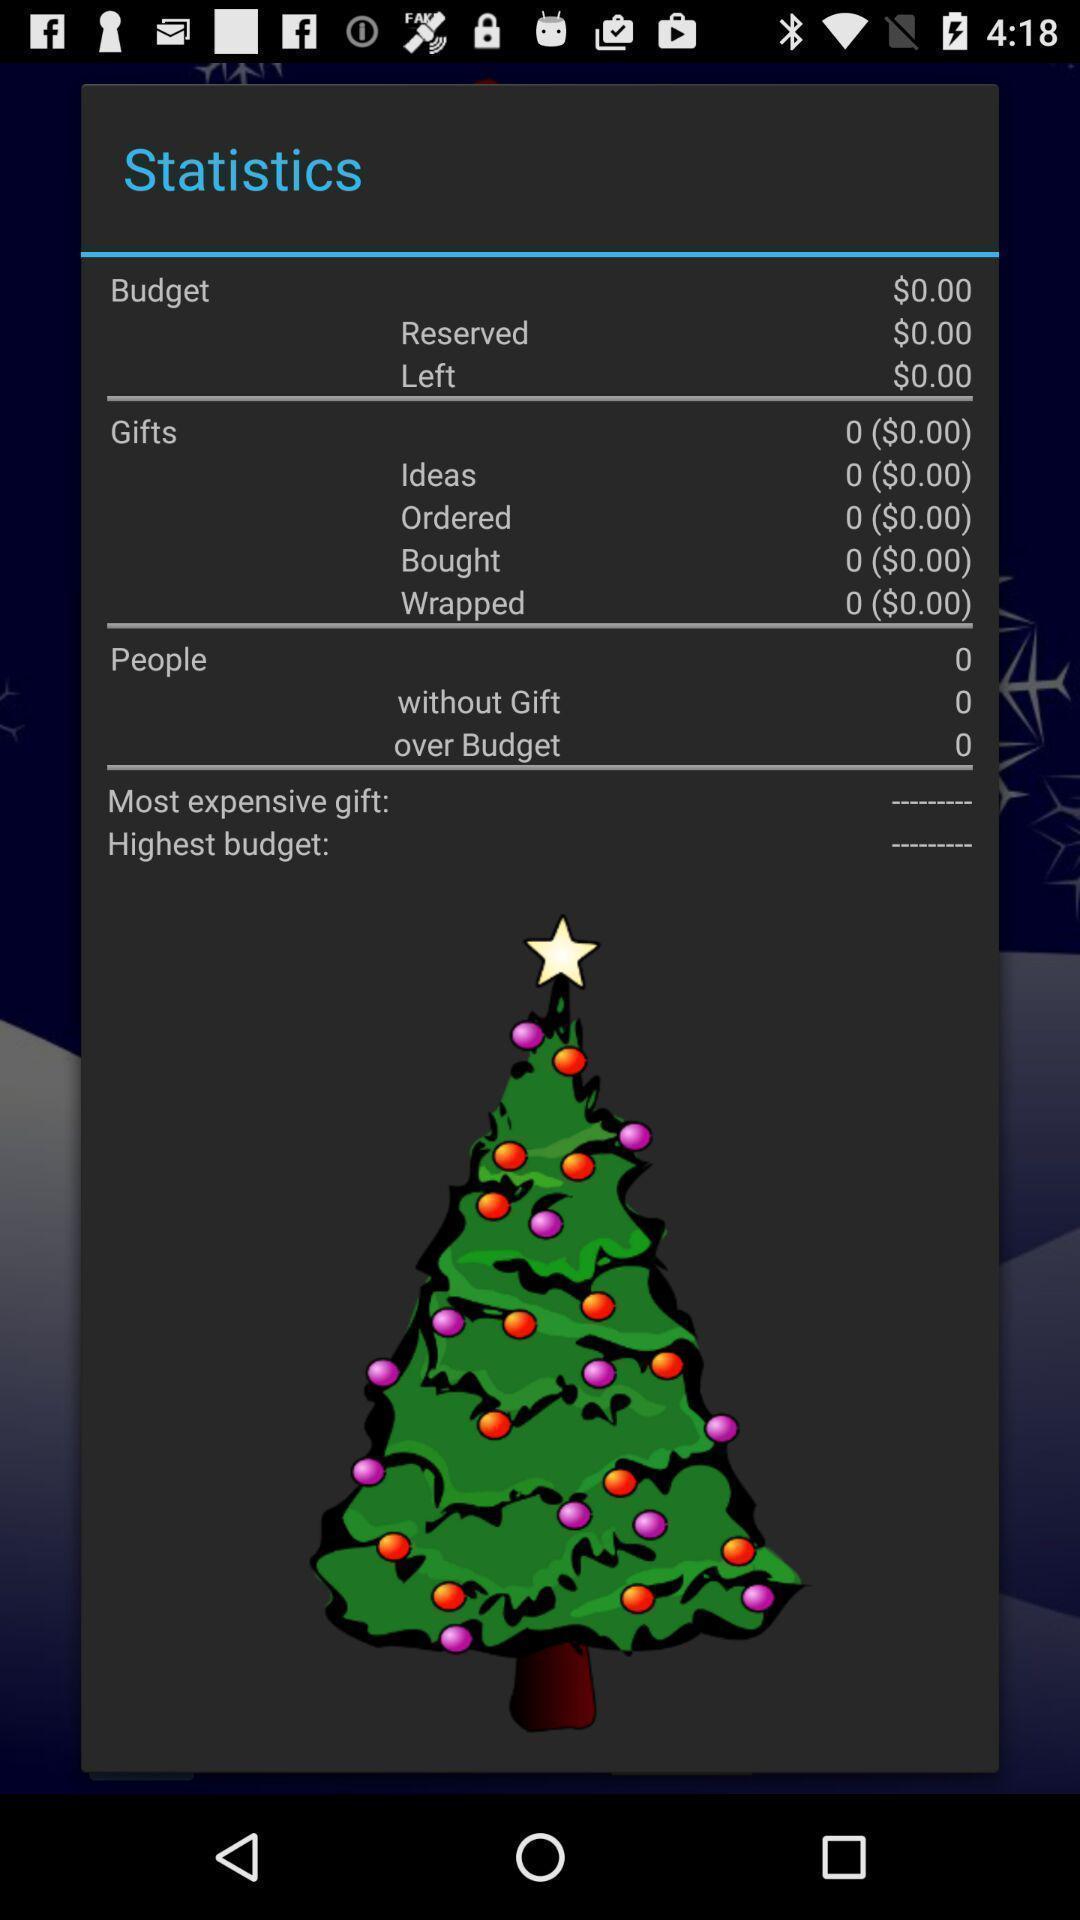What is the overall content of this screenshot? Screen shows statistics details. 